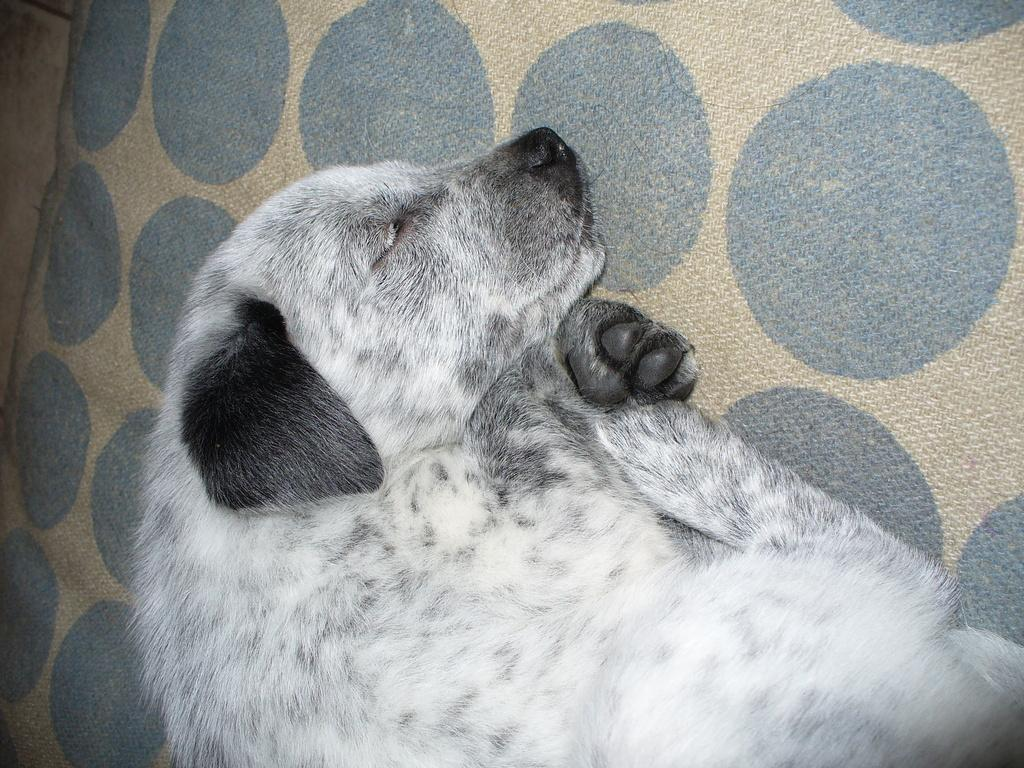What type of animal can be seen in the image? There is a dog in the image. What is the dog doing in the image? The dog is sleeping. What can be seen in the background of the image? There is a mat in the background of the image. What type of destruction can be seen in the image caused by the pigs? There is no destruction or pigs present in the image; it features a dog sleeping on a mat. 